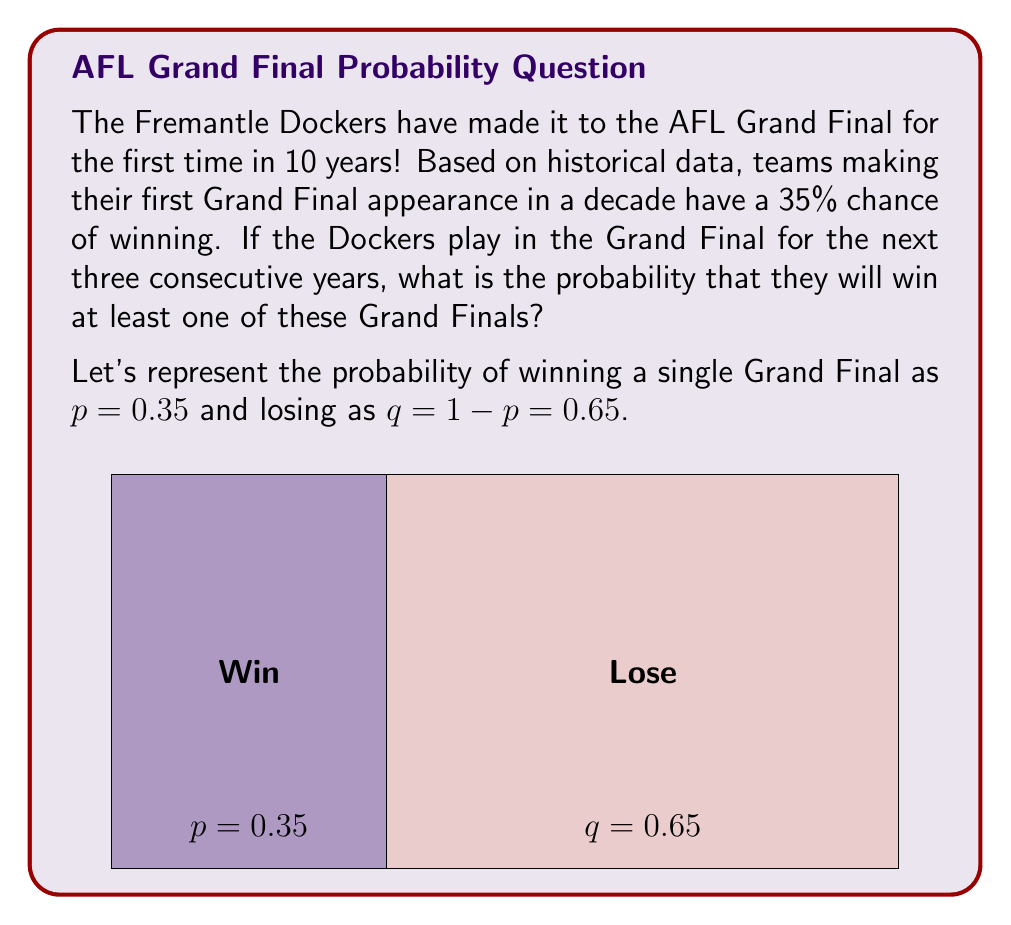What is the answer to this math problem? To solve this problem, we'll use the complement rule of probability. Instead of calculating the probability of winning at least one Grand Final, we'll calculate the probability of losing all three and then subtract that from 1.

Step 1: Calculate the probability of losing all three Grand Finals.
$$P(\text{lose all three}) = q^3 = 0.65^3 = 0.274625$$

Step 2: Use the complement rule to find the probability of winning at least one Grand Final.
$$P(\text{win at least one}) = 1 - P(\text{lose all three})$$
$$P(\text{win at least one}) = 1 - 0.274625 = 0.725375$$

Step 3: Convert the result to a percentage.
$$0.725375 \times 100\% = 72.5375\%$$

Therefore, the probability that the Fremantle Dockers will win at least one of the next three Grand Finals is approximately 72.54%.
Answer: $72.54\%$ 